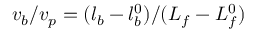<formula> <loc_0><loc_0><loc_500><loc_500>v _ { b } / v _ { p } = ( l _ { b } - l _ { b } ^ { 0 } ) / ( L _ { f } - L _ { f } ^ { 0 } )</formula> 